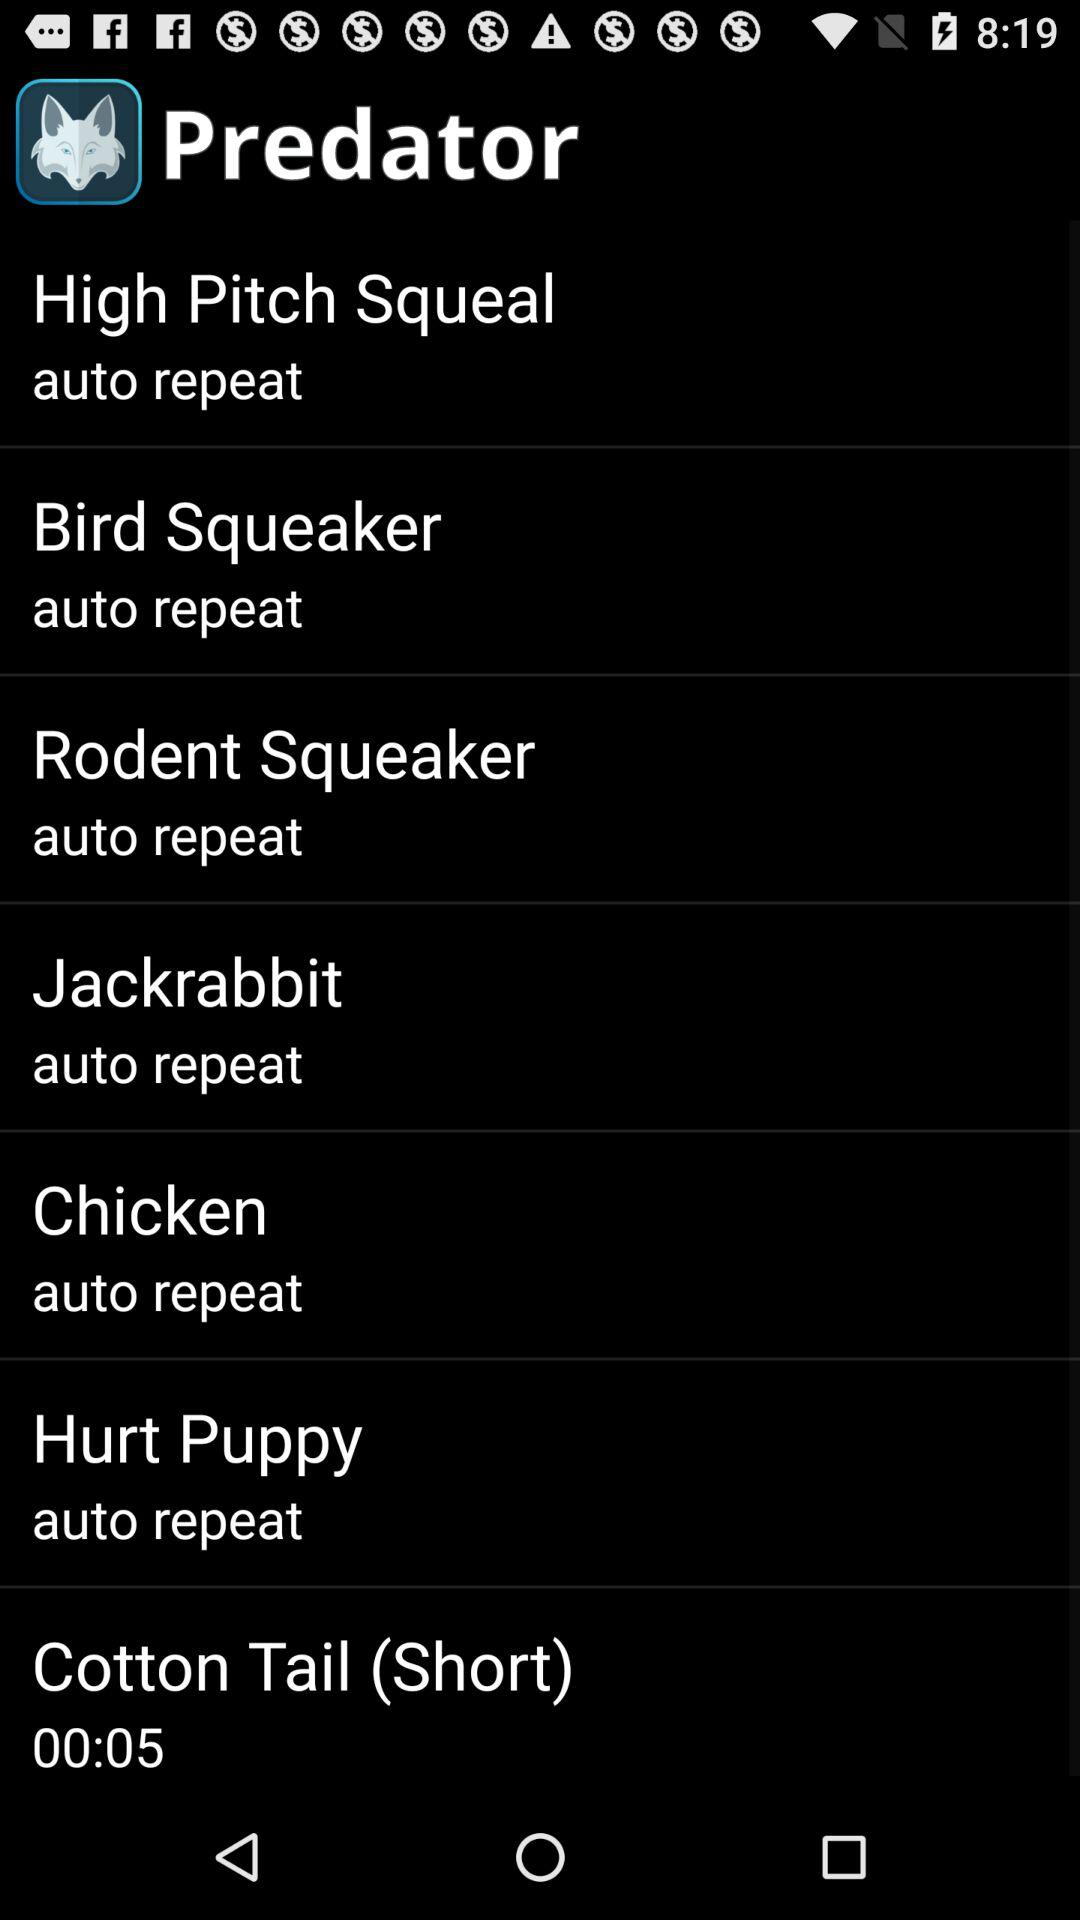How long is the Cotton Tail (Short) sound effect?
Answer the question using a single word or phrase. 00:05 